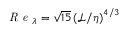<formula> <loc_0><loc_0><loc_500><loc_500>R e _ { \lambda } = \sqrt { 1 5 } \left ( \mathcal { L } / \eta \right ) ^ { 4 / 3 }</formula> 